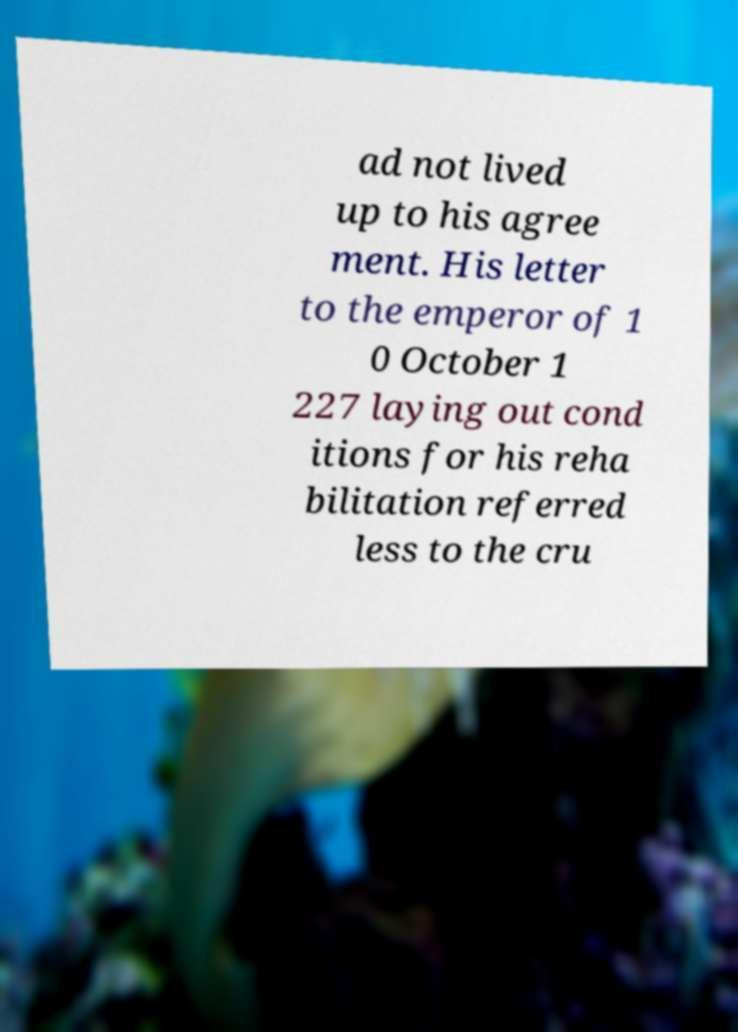Please read and relay the text visible in this image. What does it say? ad not lived up to his agree ment. His letter to the emperor of 1 0 October 1 227 laying out cond itions for his reha bilitation referred less to the cru 